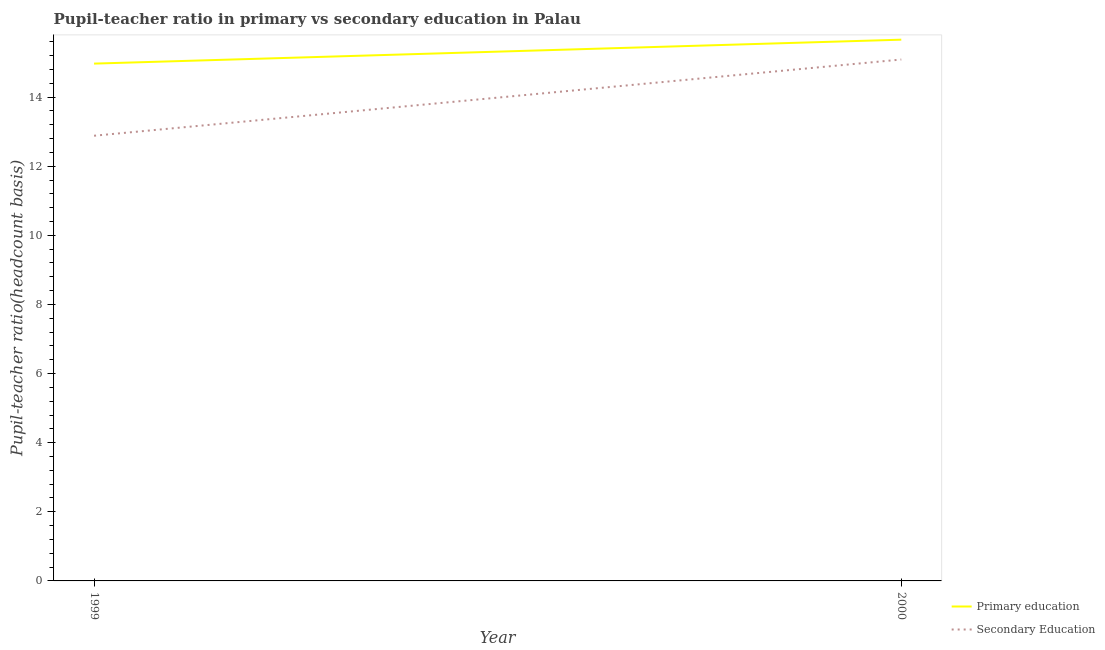Does the line corresponding to pupil teacher ratio on secondary education intersect with the line corresponding to pupil-teacher ratio in primary education?
Offer a terse response. No. Is the number of lines equal to the number of legend labels?
Your answer should be very brief. Yes. What is the pupil teacher ratio on secondary education in 1999?
Provide a succinct answer. 12.88. Across all years, what is the maximum pupil teacher ratio on secondary education?
Your answer should be very brief. 15.09. Across all years, what is the minimum pupil-teacher ratio in primary education?
Your response must be concise. 14.97. In which year was the pupil teacher ratio on secondary education maximum?
Offer a very short reply. 2000. In which year was the pupil-teacher ratio in primary education minimum?
Your response must be concise. 1999. What is the total pupil-teacher ratio in primary education in the graph?
Keep it short and to the point. 30.63. What is the difference between the pupil teacher ratio on secondary education in 1999 and that in 2000?
Offer a very short reply. -2.21. What is the difference between the pupil teacher ratio on secondary education in 2000 and the pupil-teacher ratio in primary education in 1999?
Ensure brevity in your answer.  0.12. What is the average pupil teacher ratio on secondary education per year?
Your answer should be very brief. 13.98. In the year 2000, what is the difference between the pupil teacher ratio on secondary education and pupil-teacher ratio in primary education?
Ensure brevity in your answer.  -0.57. What is the ratio of the pupil teacher ratio on secondary education in 1999 to that in 2000?
Ensure brevity in your answer.  0.85. In how many years, is the pupil teacher ratio on secondary education greater than the average pupil teacher ratio on secondary education taken over all years?
Provide a succinct answer. 1. Does the pupil teacher ratio on secondary education monotonically increase over the years?
Offer a terse response. Yes. Is the pupil-teacher ratio in primary education strictly greater than the pupil teacher ratio on secondary education over the years?
Give a very brief answer. Yes. How many years are there in the graph?
Your answer should be compact. 2. Does the graph contain any zero values?
Make the answer very short. No. Where does the legend appear in the graph?
Keep it short and to the point. Bottom right. How are the legend labels stacked?
Your answer should be compact. Vertical. What is the title of the graph?
Your response must be concise. Pupil-teacher ratio in primary vs secondary education in Palau. What is the label or title of the Y-axis?
Keep it short and to the point. Pupil-teacher ratio(headcount basis). What is the Pupil-teacher ratio(headcount basis) in Primary education in 1999?
Your response must be concise. 14.97. What is the Pupil-teacher ratio(headcount basis) of Secondary Education in 1999?
Ensure brevity in your answer.  12.88. What is the Pupil-teacher ratio(headcount basis) in Primary education in 2000?
Ensure brevity in your answer.  15.66. What is the Pupil-teacher ratio(headcount basis) of Secondary Education in 2000?
Offer a terse response. 15.09. Across all years, what is the maximum Pupil-teacher ratio(headcount basis) of Primary education?
Give a very brief answer. 15.66. Across all years, what is the maximum Pupil-teacher ratio(headcount basis) in Secondary Education?
Provide a succinct answer. 15.09. Across all years, what is the minimum Pupil-teacher ratio(headcount basis) in Primary education?
Your answer should be compact. 14.97. Across all years, what is the minimum Pupil-teacher ratio(headcount basis) in Secondary Education?
Make the answer very short. 12.88. What is the total Pupil-teacher ratio(headcount basis) of Primary education in the graph?
Your response must be concise. 30.63. What is the total Pupil-teacher ratio(headcount basis) of Secondary Education in the graph?
Provide a succinct answer. 27.97. What is the difference between the Pupil-teacher ratio(headcount basis) of Primary education in 1999 and that in 2000?
Give a very brief answer. -0.69. What is the difference between the Pupil-teacher ratio(headcount basis) in Secondary Education in 1999 and that in 2000?
Ensure brevity in your answer.  -2.21. What is the difference between the Pupil-teacher ratio(headcount basis) of Primary education in 1999 and the Pupil-teacher ratio(headcount basis) of Secondary Education in 2000?
Make the answer very short. -0.12. What is the average Pupil-teacher ratio(headcount basis) of Primary education per year?
Provide a short and direct response. 15.31. What is the average Pupil-teacher ratio(headcount basis) in Secondary Education per year?
Provide a short and direct response. 13.98. In the year 1999, what is the difference between the Pupil-teacher ratio(headcount basis) of Primary education and Pupil-teacher ratio(headcount basis) of Secondary Education?
Provide a short and direct response. 2.09. In the year 2000, what is the difference between the Pupil-teacher ratio(headcount basis) in Primary education and Pupil-teacher ratio(headcount basis) in Secondary Education?
Your response must be concise. 0.57. What is the ratio of the Pupil-teacher ratio(headcount basis) of Primary education in 1999 to that in 2000?
Offer a very short reply. 0.96. What is the ratio of the Pupil-teacher ratio(headcount basis) in Secondary Education in 1999 to that in 2000?
Ensure brevity in your answer.  0.85. What is the difference between the highest and the second highest Pupil-teacher ratio(headcount basis) in Primary education?
Your answer should be compact. 0.69. What is the difference between the highest and the second highest Pupil-teacher ratio(headcount basis) of Secondary Education?
Provide a short and direct response. 2.21. What is the difference between the highest and the lowest Pupil-teacher ratio(headcount basis) of Primary education?
Give a very brief answer. 0.69. What is the difference between the highest and the lowest Pupil-teacher ratio(headcount basis) in Secondary Education?
Provide a succinct answer. 2.21. 